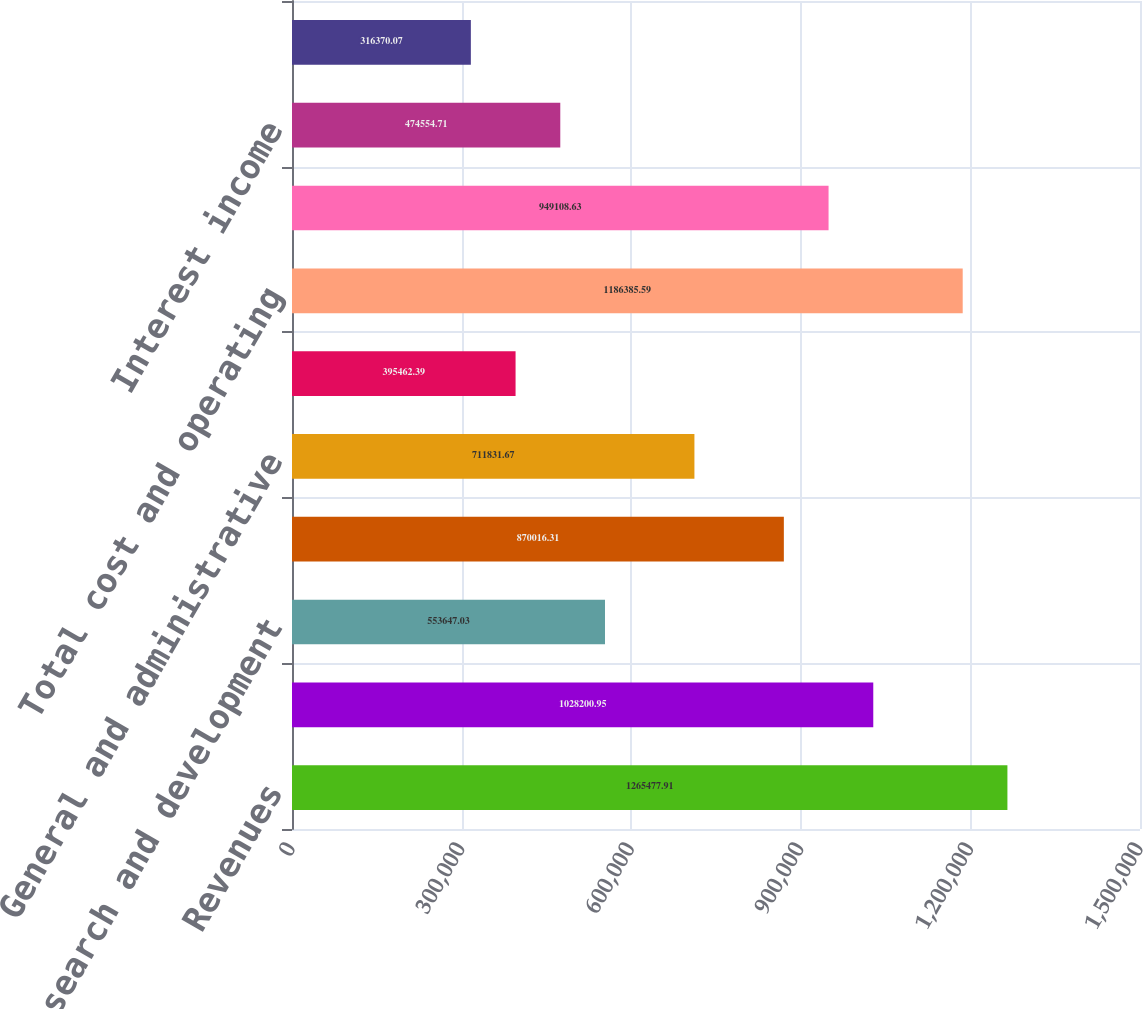<chart> <loc_0><loc_0><loc_500><loc_500><bar_chart><fcel>Revenues<fcel>Cost of revenues<fcel>Research and development<fcel>Sales and marketing<fcel>General and administrative<fcel>Amortization of other<fcel>Total cost and operating<fcel>Income from operations<fcel>Interest income<fcel>Interest expense<nl><fcel>1.26548e+06<fcel>1.0282e+06<fcel>553647<fcel>870016<fcel>711832<fcel>395462<fcel>1.18639e+06<fcel>949109<fcel>474555<fcel>316370<nl></chart> 